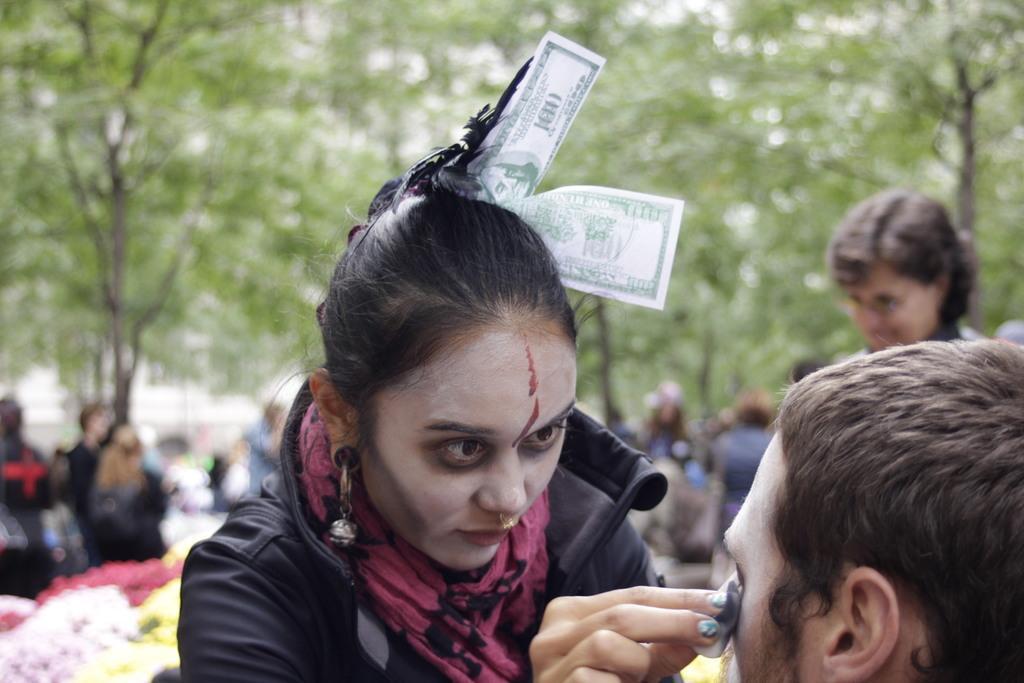Could you give a brief overview of what you see in this image? In this picture there is a woman holding the object and there is a money on her hair. At the back there are group of people and there are flowers and trees and there is a building. 